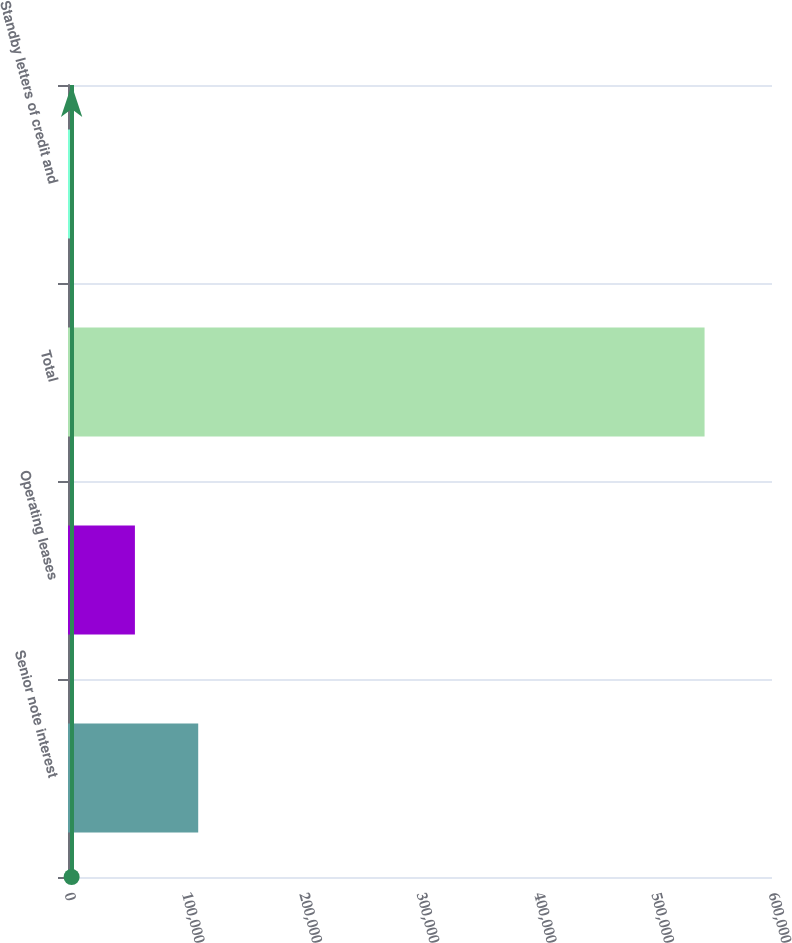Convert chart. <chart><loc_0><loc_0><loc_500><loc_500><bar_chart><fcel>Senior note interest<fcel>Operating leases<fcel>Total<fcel>Standby letters of credit and<nl><fcel>110977<fcel>57032.3<fcel>542531<fcel>3088<nl></chart> 